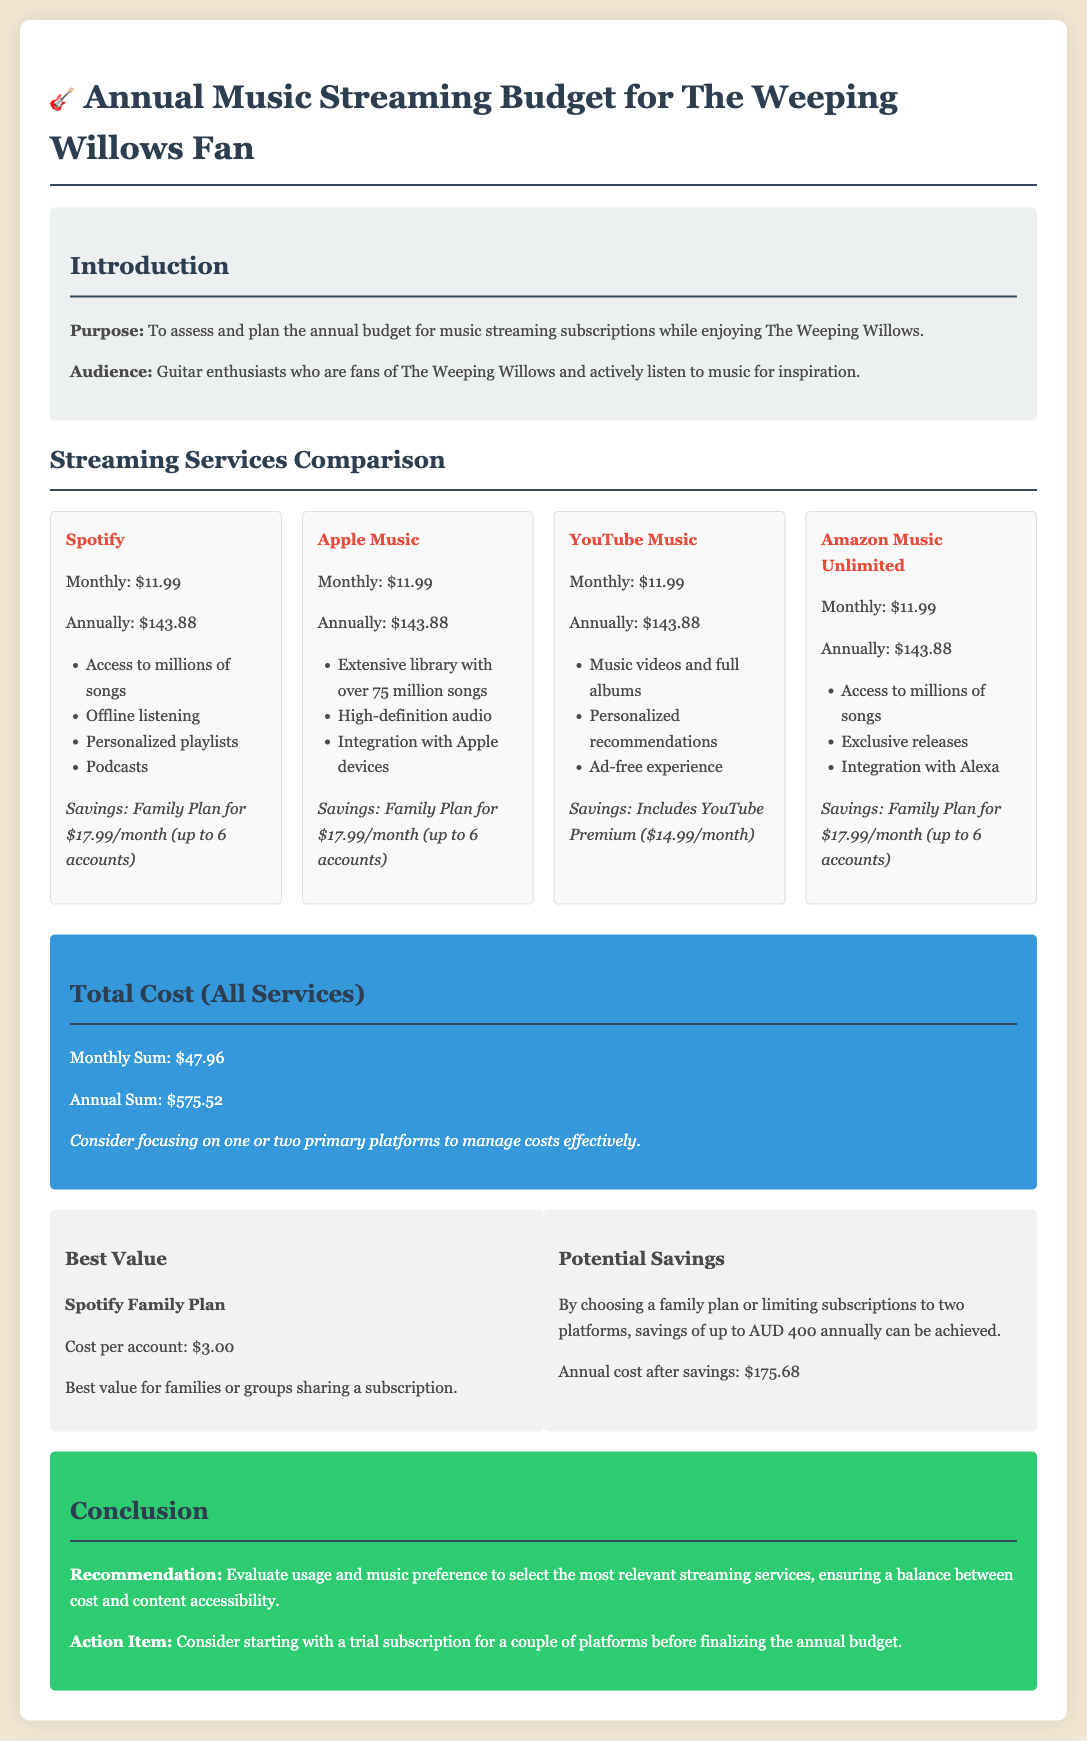What is the total annual cost for all streaming services? The total annual cost is calculated as the sum of the annual costs of each streaming service, which totals $575.52.
Answer: $575.52 What is the monthly cost for the Spotify service? The monthly cost for Spotify is explicitly listed in the document.
Answer: $11.99 How much can be saved annually by limiting subscriptions to two platforms? The document states that savings of up to AUD 400 can be achieved by limiting subscriptions.
Answer: AUD 400 Which service offers high-definition audio? The service that specifically mentions high-definition audio is Apple Music.
Answer: Apple Music What is the family plan cost for Spotify? The family plan cost is mentioned directly in the comparison section of the document.
Answer: $17.99 What is the cost per account for the Spotify Family Plan? The document provides the cost per account when using the Spotify Family Plan.
Answer: $3.00 Which platform includes YouTube Premium? The document highlights that YouTube Music includes YouTube Premium as part of its offering.
Answer: YouTube Music What is the annual cost after potential savings? The document indicates the annual cost after potential savings is achieved.
Answer: $175.68 